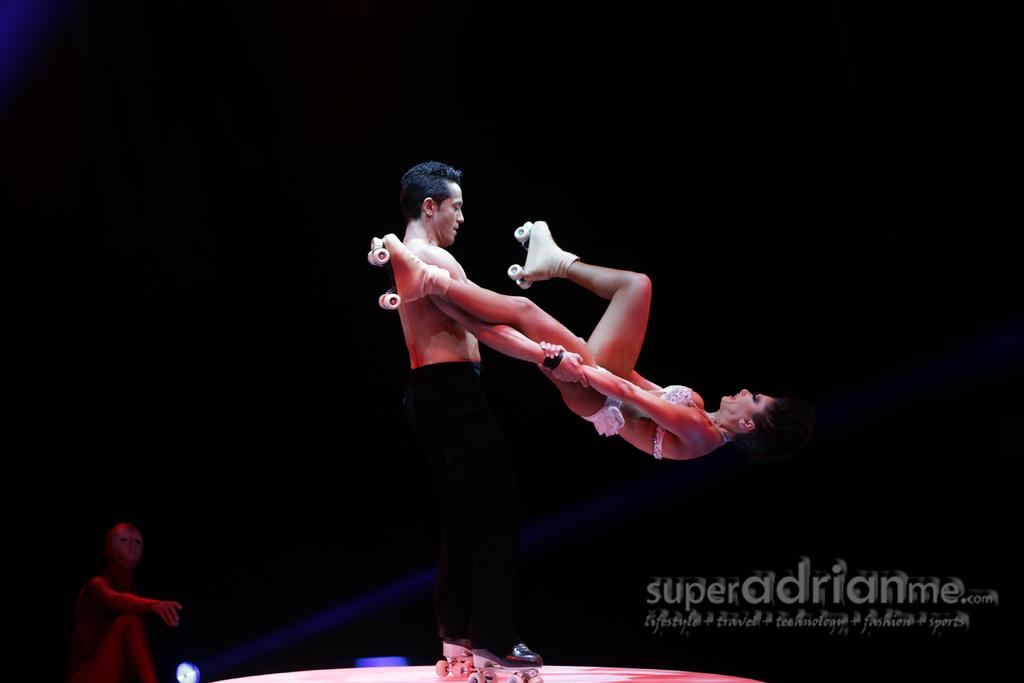How many people with skate shoes are in the image? There are two people with skate shoes in the image. Can you describe the position of the other person in relation to the two people with skate shoes? There is another person to the left of the two people with skate shoes. What is the color of the background in the image? The background of the image is black. How far away is the baby from the people with skate shoes in the image? There is no baby present in the image, so it is not possible to determine the distance between a baby and the people with skate shoes. 